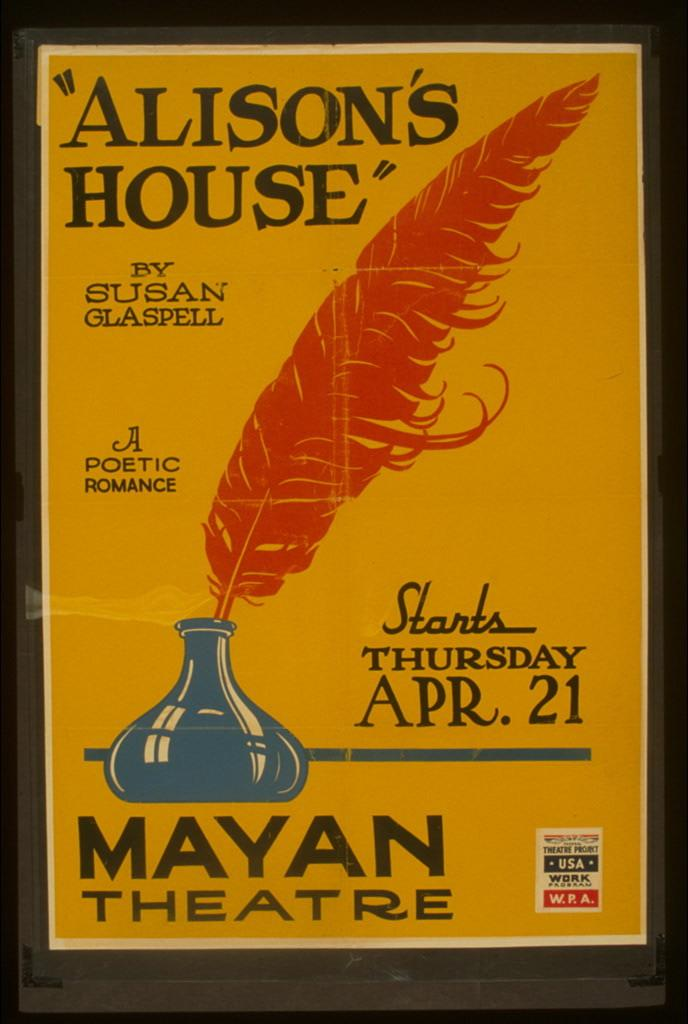<image>
Summarize the visual content of the image. a paper that says 'alison's house' by susan glaspell 